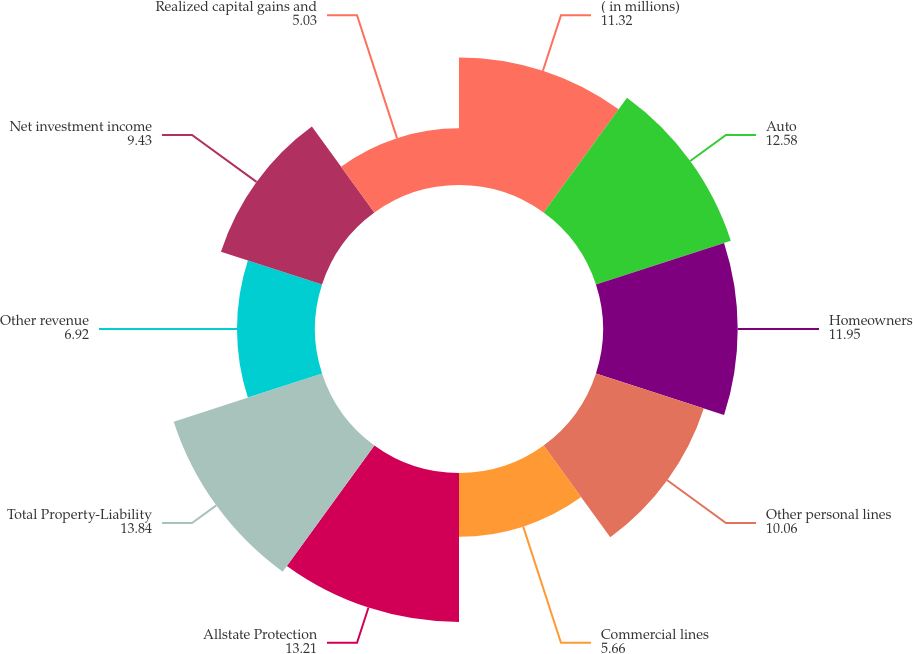Convert chart. <chart><loc_0><loc_0><loc_500><loc_500><pie_chart><fcel>( in millions)<fcel>Auto<fcel>Homeowners<fcel>Other personal lines<fcel>Commercial lines<fcel>Allstate Protection<fcel>Total Property-Liability<fcel>Other revenue<fcel>Net investment income<fcel>Realized capital gains and<nl><fcel>11.32%<fcel>12.58%<fcel>11.95%<fcel>10.06%<fcel>5.66%<fcel>13.21%<fcel>13.84%<fcel>6.92%<fcel>9.43%<fcel>5.03%<nl></chart> 